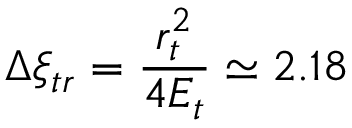Convert formula to latex. <formula><loc_0><loc_0><loc_500><loc_500>\Delta \xi _ { t r } = \frac { r _ { t } ^ { 2 } } { 4 E _ { t } } \simeq 2 . 1 8</formula> 